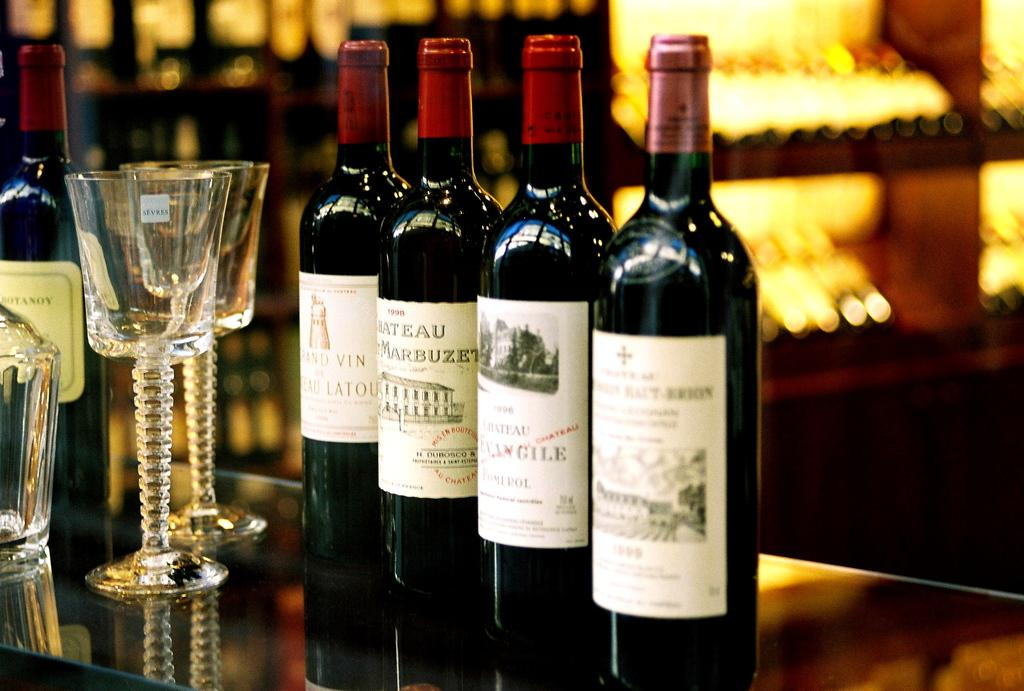<image>
Provide a brief description of the given image. Several bottles of chateau type wine lined up on a bar next to long stemware crystal glasses. 